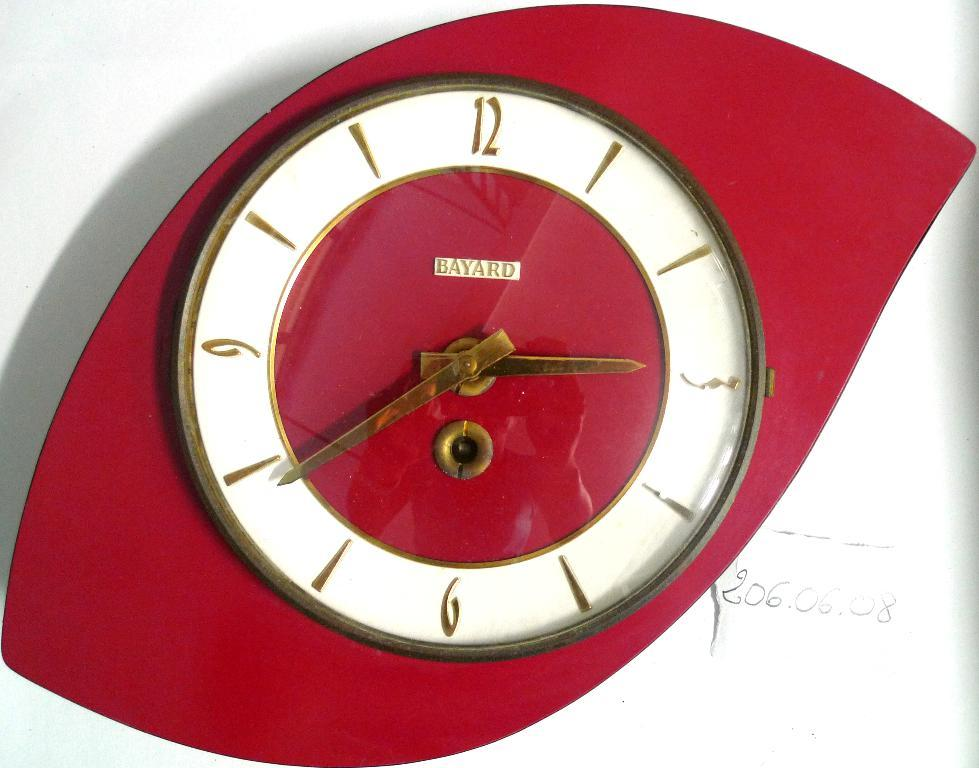<image>
Relay a brief, clear account of the picture shown. A red Bayard clock in the art deco style is mounted on a white wall. 